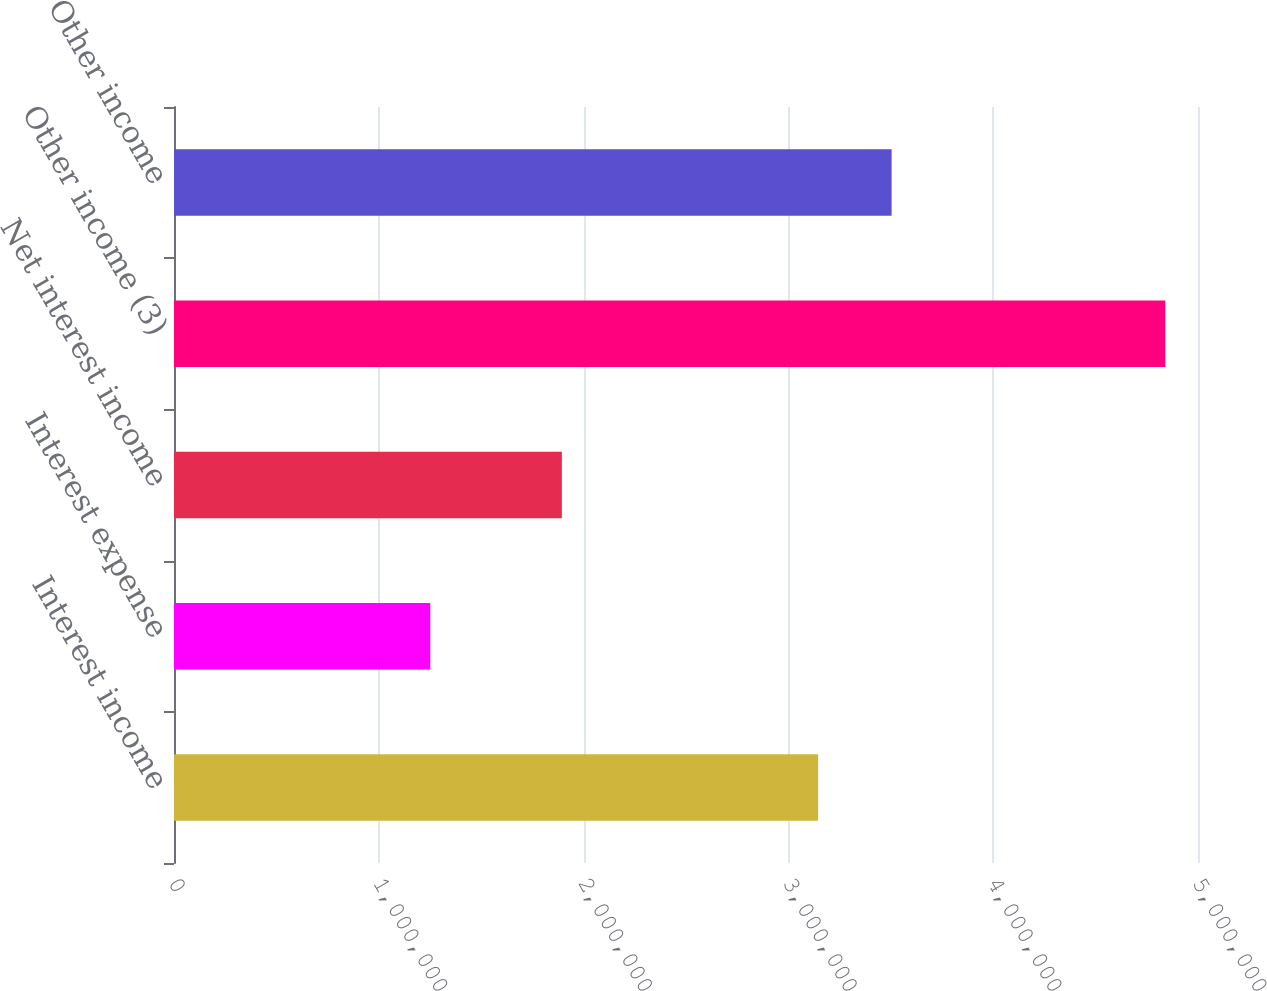<chart> <loc_0><loc_0><loc_500><loc_500><bar_chart><fcel>Interest income<fcel>Interest expense<fcel>Net interest income<fcel>Other income (3)<fcel>Other income<nl><fcel>3.14508e+06<fcel>1.25128e+06<fcel>1.8938e+06<fcel>4.8406e+06<fcel>3.50401e+06<nl></chart> 